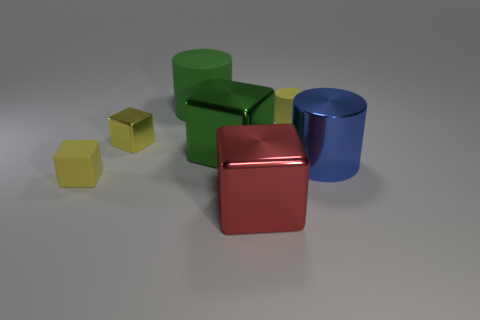How many other objects are there of the same material as the small yellow cylinder?
Give a very brief answer. 2. There is a yellow cylinder that is the same size as the yellow rubber block; what is it made of?
Your response must be concise. Rubber. There is a tiny rubber object behind the blue object; does it have the same shape as the green rubber object?
Keep it short and to the point. Yes. Is the color of the tiny cylinder the same as the tiny metallic thing?
Make the answer very short. Yes. What number of objects are either small yellow rubber things that are left of the green metal thing or small blue rubber cylinders?
Your response must be concise. 1. There is a green metal object that is the same size as the red shiny cube; what is its shape?
Make the answer very short. Cube. There is a red metal object left of the metal cylinder; does it have the same size as the matte object that is in front of the blue cylinder?
Your response must be concise. No. There is another cylinder that is the same material as the small yellow cylinder; what is its color?
Provide a short and direct response. Green. Do the big cylinder in front of the green block and the tiny cube that is behind the green block have the same material?
Offer a very short reply. Yes. Are there any blue objects that have the same size as the green metallic block?
Provide a succinct answer. Yes. 